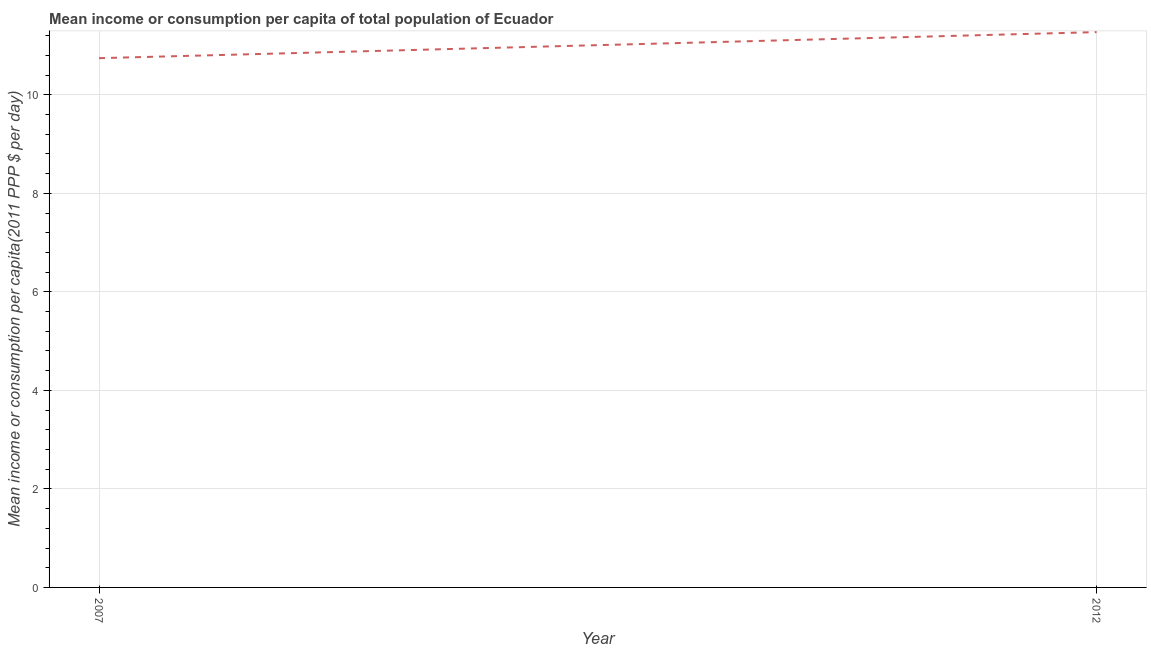What is the mean income or consumption in 2007?
Your answer should be very brief. 10.74. Across all years, what is the maximum mean income or consumption?
Give a very brief answer. 11.27. Across all years, what is the minimum mean income or consumption?
Your answer should be very brief. 10.74. What is the sum of the mean income or consumption?
Your response must be concise. 22.02. What is the difference between the mean income or consumption in 2007 and 2012?
Ensure brevity in your answer.  -0.53. What is the average mean income or consumption per year?
Provide a short and direct response. 11.01. What is the median mean income or consumption?
Your answer should be compact. 11.01. In how many years, is the mean income or consumption greater than 4.4 $?
Keep it short and to the point. 2. What is the ratio of the mean income or consumption in 2007 to that in 2012?
Keep it short and to the point. 0.95. In how many years, is the mean income or consumption greater than the average mean income or consumption taken over all years?
Offer a terse response. 1. How many lines are there?
Keep it short and to the point. 1. How many years are there in the graph?
Make the answer very short. 2. What is the difference between two consecutive major ticks on the Y-axis?
Give a very brief answer. 2. Are the values on the major ticks of Y-axis written in scientific E-notation?
Offer a terse response. No. Does the graph contain any zero values?
Your answer should be very brief. No. What is the title of the graph?
Your answer should be very brief. Mean income or consumption per capita of total population of Ecuador. What is the label or title of the X-axis?
Your answer should be compact. Year. What is the label or title of the Y-axis?
Ensure brevity in your answer.  Mean income or consumption per capita(2011 PPP $ per day). What is the Mean income or consumption per capita(2011 PPP $ per day) of 2007?
Ensure brevity in your answer.  10.74. What is the Mean income or consumption per capita(2011 PPP $ per day) of 2012?
Keep it short and to the point. 11.27. What is the difference between the Mean income or consumption per capita(2011 PPP $ per day) in 2007 and 2012?
Offer a terse response. -0.53. What is the ratio of the Mean income or consumption per capita(2011 PPP $ per day) in 2007 to that in 2012?
Your response must be concise. 0.95. 